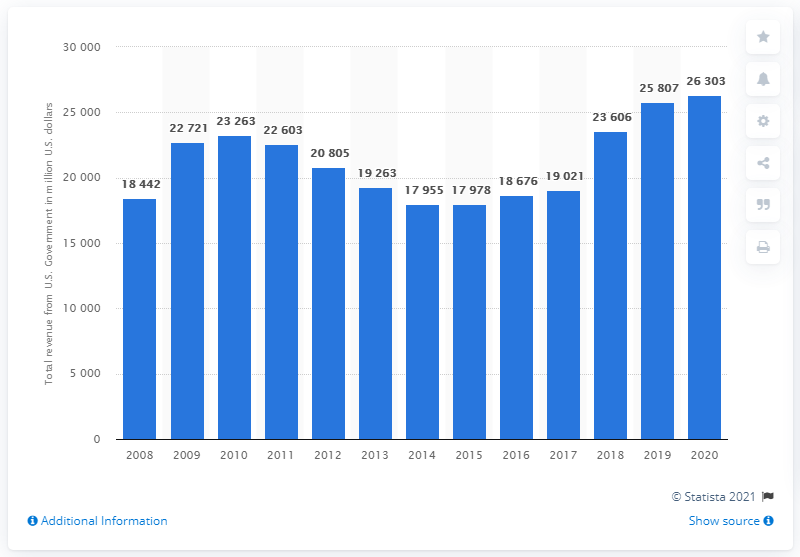Mention a couple of crucial points in this snapshot. The revenue generated by General Dynamics from the U.S. government in 2020 was approximately 26,303. 